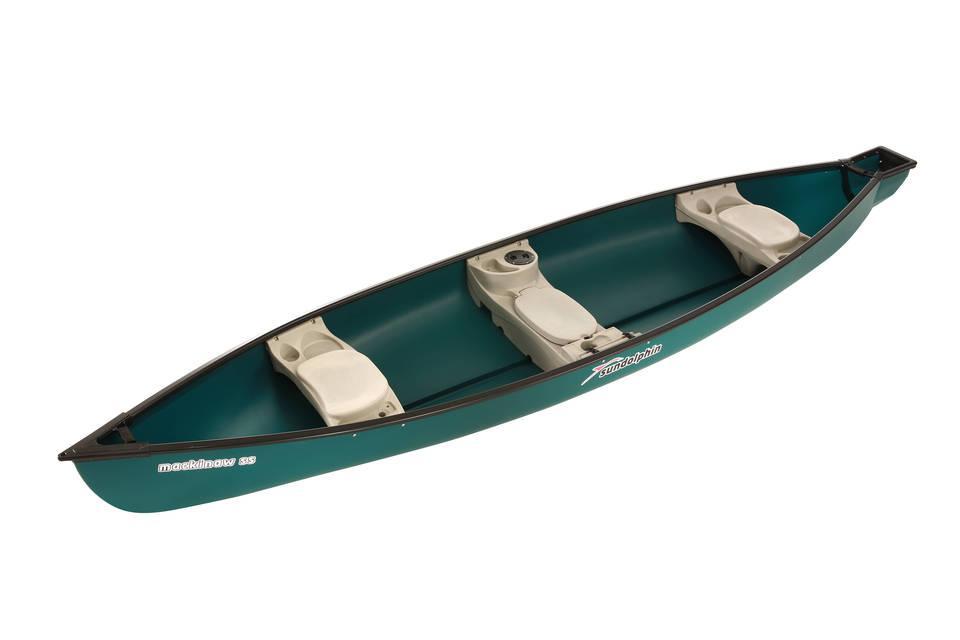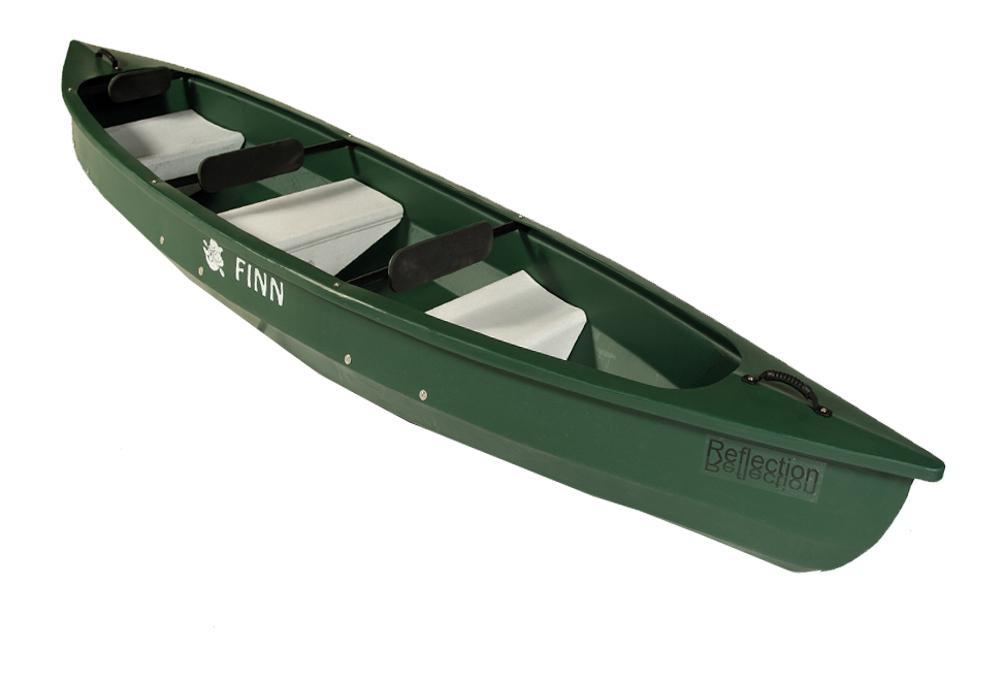The first image is the image on the left, the second image is the image on the right. For the images displayed, is the sentence "the right side pic has a boat with seats that have back rests" factually correct? Answer yes or no. No. The first image is the image on the left, the second image is the image on the right. For the images displayed, is the sentence "there are 6 seats in the canoe  in the image pair" factually correct? Answer yes or no. Yes. 